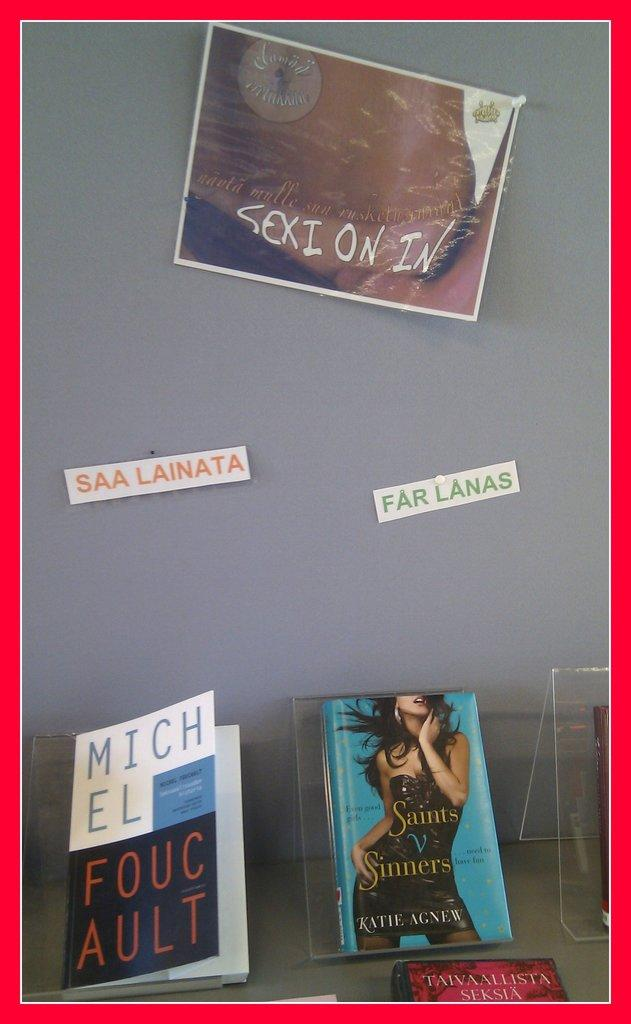Provide a one-sentence caption for the provided image. Two books, on e is called Saints v sinners by katie agnew. 